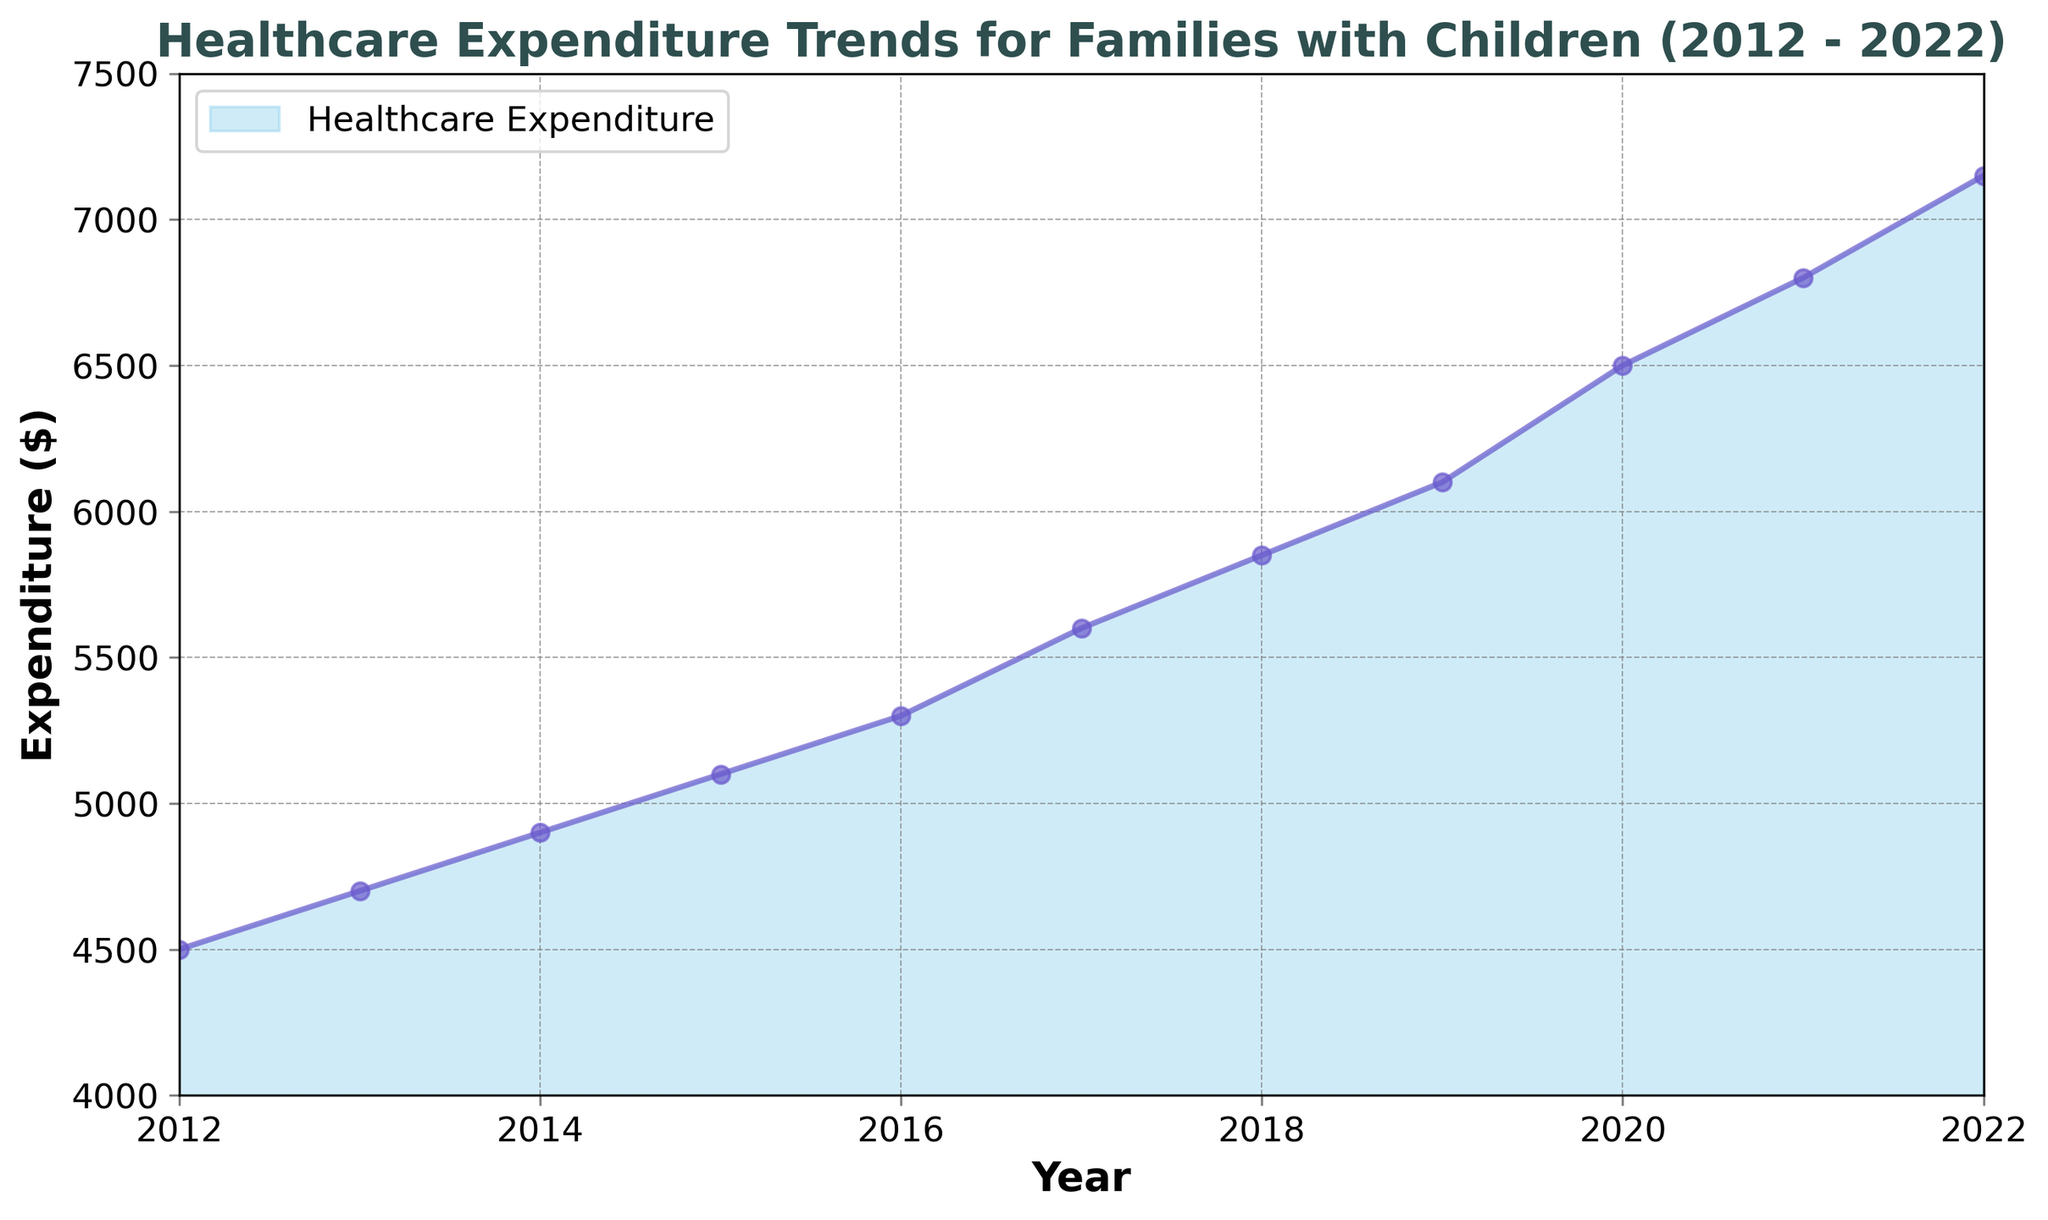Which year had the highest healthcare expenditure for families with children? The highest healthcare expenditure can be identified by the peak point on the area plot. The plot shows the highest point in 2022.
Answer: 2022 How much did healthcare expenditure increase from 2012 to 2022? Subtract the healthcare expenditure value in 2012 from the value in 2022: 7150 - 4500 = 2650.
Answer: 2650 By how much did the healthcare expenditure increase between 2019 and 2020? Subtract the healthcare expenditure value in 2019 from the value in 2020: 6500 - 6100 = 400.
Answer: 400 What is the average annual healthcare expenditure from 2012 to 2022? Sum all yearly expenditures and divide by the number of years. (4500 + 4700 + 4900 + 5100 + 5300 + 5600 + 5850 + 6100 + 6500 + 6800 + 7150) / 11 = 5786.36.
Answer: 5786.36 Which year saw the largest increase in healthcare expenditure compared to the previous year? Calculate the yearly differences and identify the largest one. The largest yearly increase was from 2020 to 2021, where it increased by 6800 - 6500 = 300.
Answer: 2020 to 2021 What color represents the healthcare expenditure area on the plot? The area representing healthcare expenditure is colored in sky blue, as seen in the figure.
Answer: Sky blue In which year did healthcare expenditure first exceed $6000? The plot shows that healthcare expenditure exceeds $6000 in the year 2019.
Answer: 2019 Compare the healthcare expenditure in 2015 and 2017. Which year had higher expenditure and by how much? The plot shows healthcare expenditure in 2015 was $5100 and in 2017 was $5600. Subtract to find the difference: 5600 - 5100 = 500. Thus, 2017 had $500 higher expenditure.
Answer: 2017 by 500 Is there any year where the healthcare expenditure remained the same as the previous year? By comparing the yearly data points on the plot, we see that there's no year where the expenditure remained the same.
Answer: No What is the minimum healthcare expenditure recorded during the period? The minimum expenditure is the lowest point on the plot, which is 4500 in the year 2012.
Answer: 4500 